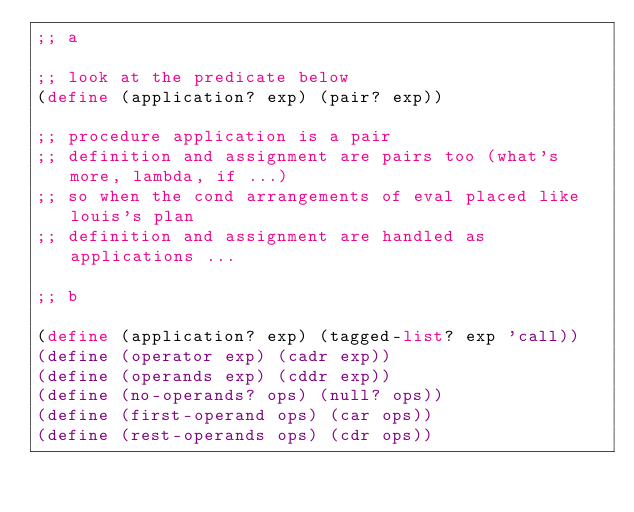<code> <loc_0><loc_0><loc_500><loc_500><_Scheme_>;; a

;; look at the predicate below
(define (application? exp) (pair? exp))

;; procedure application is a pair
;; definition and assignment are pairs too (what's more, lambda, if ...)
;; so when the cond arrangements of eval placed like louis's plan
;; definition and assignment are handled as applications ...

;; b

(define (application? exp) (tagged-list? exp 'call))
(define (operator exp) (cadr exp))
(define (operands exp) (cddr exp))
(define (no-operands? ops) (null? ops))
(define (first-operand ops) (car ops))
(define (rest-operands ops) (cdr ops))
</code> 